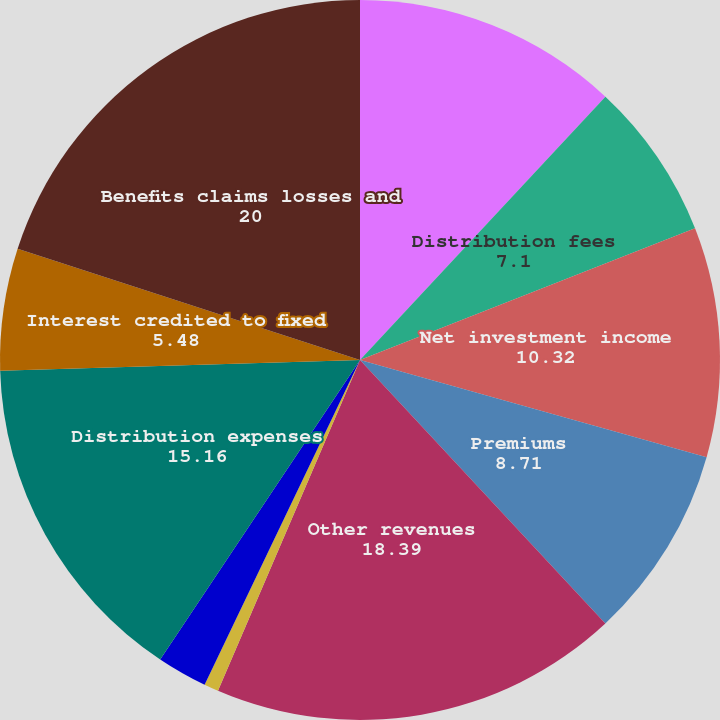Convert chart. <chart><loc_0><loc_0><loc_500><loc_500><pie_chart><fcel>Management and financial<fcel>Distribution fees<fcel>Net investment income<fcel>Premiums<fcel>Other revenues<fcel>Total revenues<fcel>Total net revenues<fcel>Distribution expenses<fcel>Interest credited to fixed<fcel>Benefits claims losses and<nl><fcel>11.94%<fcel>7.1%<fcel>10.32%<fcel>8.71%<fcel>18.39%<fcel>0.65%<fcel>2.26%<fcel>15.16%<fcel>5.48%<fcel>20.0%<nl></chart> 